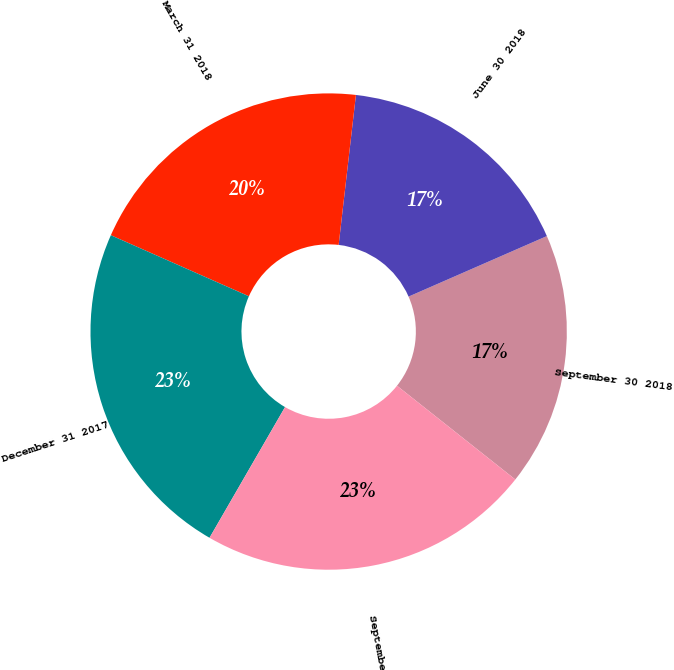Convert chart. <chart><loc_0><loc_0><loc_500><loc_500><pie_chart><fcel>September 30 2018<fcel>June 30 2018<fcel>March 31 2018<fcel>December 31 2017<fcel>September 30 2017<nl><fcel>17.23%<fcel>16.61%<fcel>20.2%<fcel>23.29%<fcel>22.67%<nl></chart> 